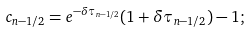Convert formula to latex. <formula><loc_0><loc_0><loc_500><loc_500>c _ { n - 1 / 2 } = e ^ { - \delta \tau _ { n - 1 / 2 } } ( 1 + \delta \tau _ { n - 1 / 2 } ) - 1 ;</formula> 